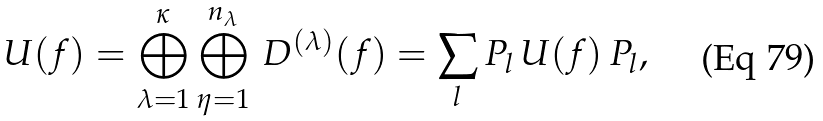Convert formula to latex. <formula><loc_0><loc_0><loc_500><loc_500>U ( f ) = \bigoplus _ { \lambda = 1 } ^ { \kappa } \bigoplus _ { \eta = 1 } ^ { n _ { \lambda } } \, D ^ { ( \lambda ) } ( f ) = \sum _ { l } P _ { l } \, U ( f ) \, P _ { l } ,</formula> 